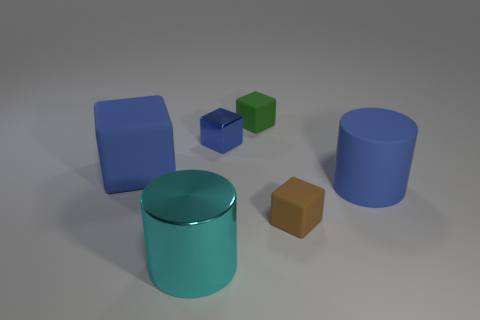Add 3 rubber cubes. How many objects exist? 9 Subtract all cylinders. How many objects are left? 4 Add 3 brown things. How many brown things are left? 4 Add 5 small yellow shiny cylinders. How many small yellow shiny cylinders exist? 5 Subtract 0 cyan balls. How many objects are left? 6 Subtract all large cyan balls. Subtract all matte things. How many objects are left? 2 